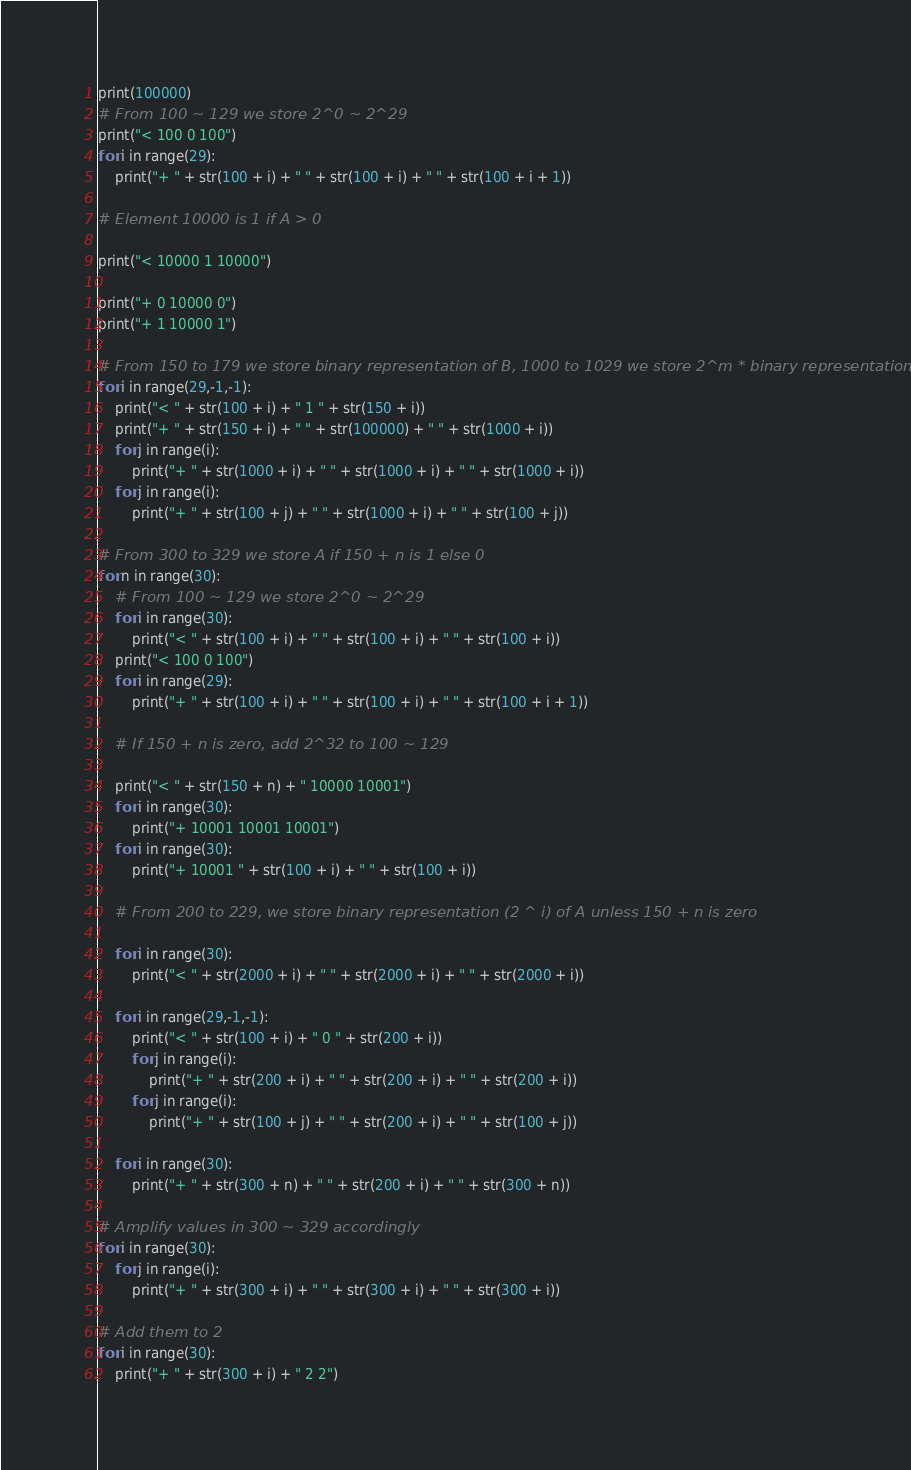<code> <loc_0><loc_0><loc_500><loc_500><_Python_>print(100000)
# From 100 ~ 129 we store 2^0 ~ 2^29
print("< 100 0 100")
for i in range(29):
    print("+ " + str(100 + i) + " " + str(100 + i) + " " + str(100 + i + 1))

# Element 10000 is 1 if A > 0

print("< 10000 1 10000")

print("+ 0 10000 0")
print("+ 1 10000 1")

# From 150 to 179 we store binary representation of B, 1000 to 1029 we store 2^m * binary representation
for i in range(29,-1,-1):
    print("< " + str(100 + i) + " 1 " + str(150 + i))
    print("+ " + str(150 + i) + " " + str(100000) + " " + str(1000 + i))
    for j in range(i):
        print("+ " + str(1000 + i) + " " + str(1000 + i) + " " + str(1000 + i))
    for j in range(i):
        print("+ " + str(100 + j) + " " + str(1000 + i) + " " + str(100 + j))

# From 300 to 329 we store A if 150 + n is 1 else 0
for n in range(30):
    # From 100 ~ 129 we store 2^0 ~ 2^29
    for i in range(30):
        print("< " + str(100 + i) + " " + str(100 + i) + " " + str(100 + i))
    print("< 100 0 100")
    for i in range(29):
        print("+ " + str(100 + i) + " " + str(100 + i) + " " + str(100 + i + 1))
    
    # If 150 + n is zero, add 2^32 to 100 ~ 129

    print("< " + str(150 + n) + " 10000 10001")
    for i in range(30):
        print("+ 10001 10001 10001")
    for i in range(30):
        print("+ 10001 " + str(100 + i) + " " + str(100 + i))

    # From 200 to 229, we store binary representation (2 ^ i) of A unless 150 + n is zero 

    for i in range(30):
        print("< " + str(2000 + i) + " " + str(2000 + i) + " " + str(2000 + i))

    for i in range(29,-1,-1):
        print("< " + str(100 + i) + " 0 " + str(200 + i))
        for j in range(i):
            print("+ " + str(200 + i) + " " + str(200 + i) + " " + str(200 + i))
        for j in range(i):
            print("+ " + str(100 + j) + " " + str(200 + i) + " " + str(100 + j))
    
    for i in range(30):
        print("+ " + str(300 + n) + " " + str(200 + i) + " " + str(300 + n))

# Amplify values in 300 ~ 329 accordingly
for i in range(30):
    for j in range(i):
        print("+ " + str(300 + i) + " " + str(300 + i) + " " + str(300 + i))

# Add them to 2
for i in range(30):
    print("+ " + str(300 + i) + " 2 2") </code> 